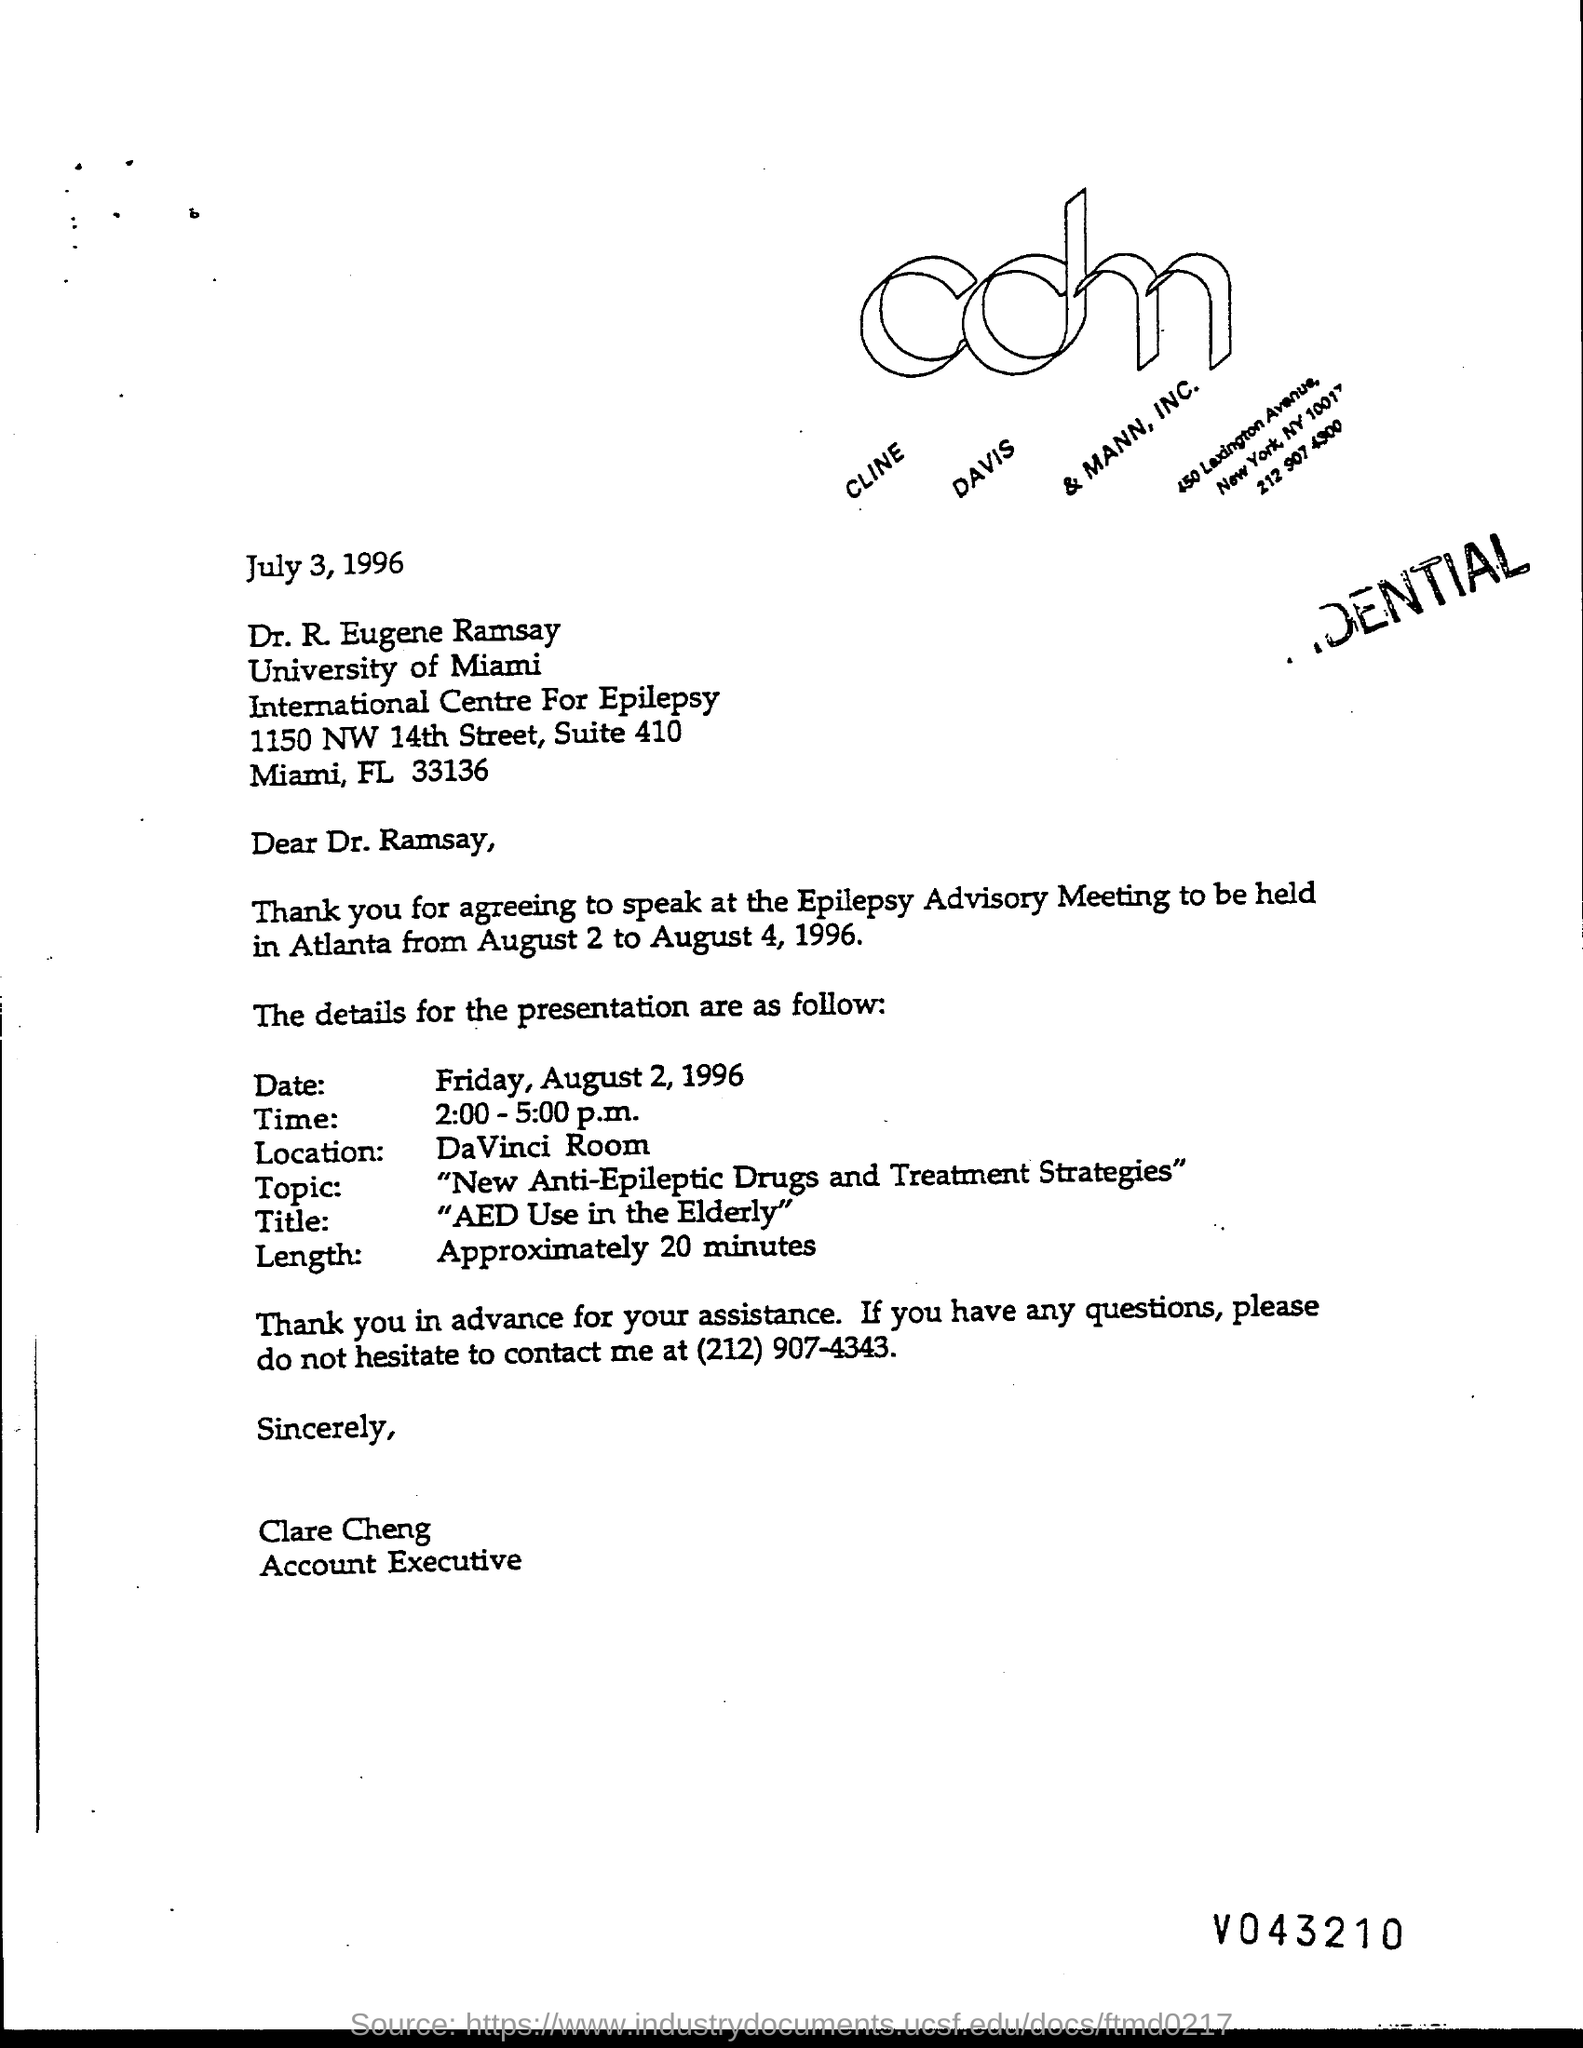What is the street address of international centre for epilepsy ?
Offer a very short reply. 1150 NW 14TH STREET. On what date is the presentation scheduled ?
Give a very brief answer. AUGUST 2, 1996. On what day of the week is the presentation scheduled?
Your response must be concise. Friday. What is the location for presentation ?
Your answer should be compact. DAVINCI ROOM. What is the title of presentation ?
Provide a succinct answer. "AED Use in the Elderly". What is the position of clare cheng?
Keep it short and to the point. Account Executive. When is the letter dated ?
Your answer should be compact. July 3, 1996. 